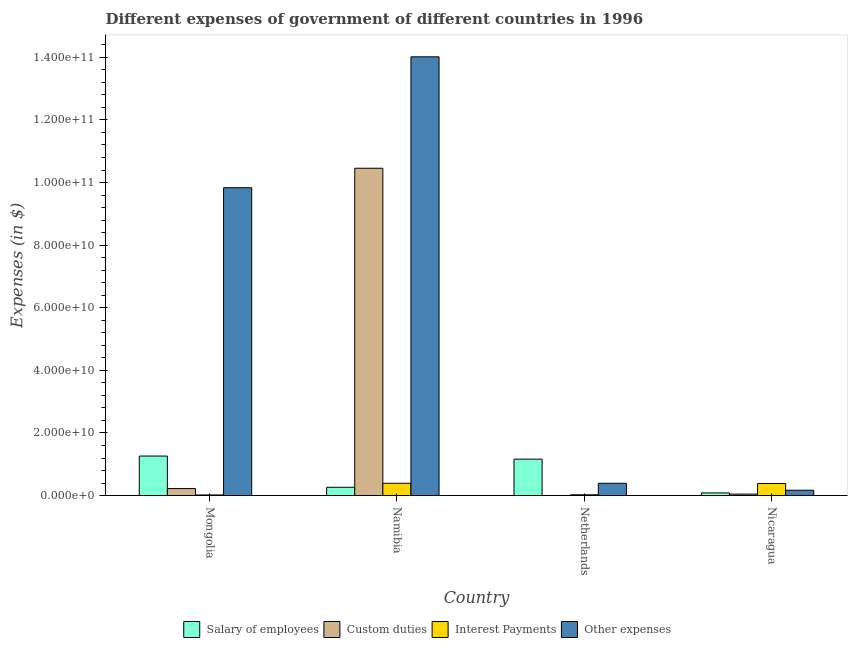How many different coloured bars are there?
Offer a terse response. 4. How many groups of bars are there?
Provide a succinct answer. 4. Are the number of bars per tick equal to the number of legend labels?
Keep it short and to the point. Yes. How many bars are there on the 4th tick from the right?
Your answer should be compact. 4. What is the label of the 4th group of bars from the left?
Offer a terse response. Nicaragua. What is the amount spent on interest payments in Netherlands?
Give a very brief answer. 2.50e+08. Across all countries, what is the maximum amount spent on custom duties?
Provide a short and direct response. 1.05e+11. Across all countries, what is the minimum amount spent on salary of employees?
Your answer should be compact. 8.45e+08. In which country was the amount spent on salary of employees maximum?
Ensure brevity in your answer.  Mongolia. In which country was the amount spent on other expenses minimum?
Your response must be concise. Nicaragua. What is the total amount spent on salary of employees in the graph?
Keep it short and to the point. 2.78e+1. What is the difference between the amount spent on other expenses in Mongolia and that in Netherlands?
Keep it short and to the point. 9.44e+1. What is the difference between the amount spent on salary of employees in Netherlands and the amount spent on other expenses in Namibia?
Your answer should be very brief. -1.29e+11. What is the average amount spent on salary of employees per country?
Offer a very short reply. 6.94e+09. What is the difference between the amount spent on interest payments and amount spent on other expenses in Mongolia?
Give a very brief answer. -9.81e+1. What is the ratio of the amount spent on custom duties in Netherlands to that in Nicaragua?
Offer a terse response. 0. What is the difference between the highest and the second highest amount spent on other expenses?
Your answer should be compact. 4.18e+1. What is the difference between the highest and the lowest amount spent on salary of employees?
Your answer should be very brief. 1.18e+1. Is it the case that in every country, the sum of the amount spent on custom duties and amount spent on salary of employees is greater than the sum of amount spent on other expenses and amount spent on interest payments?
Provide a succinct answer. No. What does the 3rd bar from the left in Mongolia represents?
Provide a short and direct response. Interest Payments. What does the 1st bar from the right in Namibia represents?
Provide a short and direct response. Other expenses. Are all the bars in the graph horizontal?
Your answer should be compact. No. How many countries are there in the graph?
Your answer should be compact. 4. What is the difference between two consecutive major ticks on the Y-axis?
Your answer should be compact. 2.00e+1. Are the values on the major ticks of Y-axis written in scientific E-notation?
Your answer should be very brief. Yes. Does the graph contain any zero values?
Offer a terse response. No. Where does the legend appear in the graph?
Keep it short and to the point. Bottom center. How are the legend labels stacked?
Provide a short and direct response. Horizontal. What is the title of the graph?
Your response must be concise. Different expenses of government of different countries in 1996. What is the label or title of the Y-axis?
Ensure brevity in your answer.  Expenses (in $). What is the Expenses (in $) in Salary of employees in Mongolia?
Make the answer very short. 1.26e+1. What is the Expenses (in $) in Custom duties in Mongolia?
Ensure brevity in your answer.  2.23e+09. What is the Expenses (in $) of Interest Payments in Mongolia?
Give a very brief answer. 1.99e+08. What is the Expenses (in $) in Other expenses in Mongolia?
Offer a terse response. 9.83e+1. What is the Expenses (in $) of Salary of employees in Namibia?
Provide a succinct answer. 2.65e+09. What is the Expenses (in $) of Custom duties in Namibia?
Keep it short and to the point. 1.05e+11. What is the Expenses (in $) of Interest Payments in Namibia?
Offer a terse response. 3.93e+09. What is the Expenses (in $) of Other expenses in Namibia?
Ensure brevity in your answer.  1.40e+11. What is the Expenses (in $) in Salary of employees in Netherlands?
Ensure brevity in your answer.  1.16e+1. What is the Expenses (in $) in Custom duties in Netherlands?
Provide a short and direct response. 7.70e+05. What is the Expenses (in $) of Interest Payments in Netherlands?
Offer a very short reply. 2.50e+08. What is the Expenses (in $) in Other expenses in Netherlands?
Keep it short and to the point. 3.93e+09. What is the Expenses (in $) in Salary of employees in Nicaragua?
Offer a very short reply. 8.45e+08. What is the Expenses (in $) in Custom duties in Nicaragua?
Provide a succinct answer. 4.63e+08. What is the Expenses (in $) in Interest Payments in Nicaragua?
Provide a succinct answer. 3.87e+09. What is the Expenses (in $) in Other expenses in Nicaragua?
Provide a short and direct response. 1.71e+09. Across all countries, what is the maximum Expenses (in $) in Salary of employees?
Offer a terse response. 1.26e+1. Across all countries, what is the maximum Expenses (in $) in Custom duties?
Offer a very short reply. 1.05e+11. Across all countries, what is the maximum Expenses (in $) in Interest Payments?
Your answer should be compact. 3.93e+09. Across all countries, what is the maximum Expenses (in $) in Other expenses?
Offer a terse response. 1.40e+11. Across all countries, what is the minimum Expenses (in $) of Salary of employees?
Provide a short and direct response. 8.45e+08. Across all countries, what is the minimum Expenses (in $) of Custom duties?
Keep it short and to the point. 7.70e+05. Across all countries, what is the minimum Expenses (in $) of Interest Payments?
Ensure brevity in your answer.  1.99e+08. Across all countries, what is the minimum Expenses (in $) in Other expenses?
Your answer should be compact. 1.71e+09. What is the total Expenses (in $) of Salary of employees in the graph?
Ensure brevity in your answer.  2.78e+1. What is the total Expenses (in $) in Custom duties in the graph?
Ensure brevity in your answer.  1.07e+11. What is the total Expenses (in $) in Interest Payments in the graph?
Your answer should be very brief. 8.25e+09. What is the total Expenses (in $) in Other expenses in the graph?
Your answer should be very brief. 2.44e+11. What is the difference between the Expenses (in $) in Salary of employees in Mongolia and that in Namibia?
Ensure brevity in your answer.  9.97e+09. What is the difference between the Expenses (in $) of Custom duties in Mongolia and that in Namibia?
Your answer should be very brief. -1.02e+11. What is the difference between the Expenses (in $) in Interest Payments in Mongolia and that in Namibia?
Make the answer very short. -3.73e+09. What is the difference between the Expenses (in $) in Other expenses in Mongolia and that in Namibia?
Give a very brief answer. -4.18e+1. What is the difference between the Expenses (in $) of Salary of employees in Mongolia and that in Netherlands?
Offer a very short reply. 9.81e+08. What is the difference between the Expenses (in $) of Custom duties in Mongolia and that in Netherlands?
Make the answer very short. 2.23e+09. What is the difference between the Expenses (in $) in Interest Payments in Mongolia and that in Netherlands?
Your response must be concise. -5.11e+07. What is the difference between the Expenses (in $) in Other expenses in Mongolia and that in Netherlands?
Provide a short and direct response. 9.44e+1. What is the difference between the Expenses (in $) in Salary of employees in Mongolia and that in Nicaragua?
Keep it short and to the point. 1.18e+1. What is the difference between the Expenses (in $) in Custom duties in Mongolia and that in Nicaragua?
Offer a terse response. 1.77e+09. What is the difference between the Expenses (in $) in Interest Payments in Mongolia and that in Nicaragua?
Give a very brief answer. -3.67e+09. What is the difference between the Expenses (in $) in Other expenses in Mongolia and that in Nicaragua?
Give a very brief answer. 9.66e+1. What is the difference between the Expenses (in $) in Salary of employees in Namibia and that in Netherlands?
Keep it short and to the point. -8.99e+09. What is the difference between the Expenses (in $) of Custom duties in Namibia and that in Netherlands?
Provide a short and direct response. 1.05e+11. What is the difference between the Expenses (in $) in Interest Payments in Namibia and that in Netherlands?
Offer a terse response. 3.68e+09. What is the difference between the Expenses (in $) of Other expenses in Namibia and that in Netherlands?
Ensure brevity in your answer.  1.36e+11. What is the difference between the Expenses (in $) of Salary of employees in Namibia and that in Nicaragua?
Make the answer very short. 1.81e+09. What is the difference between the Expenses (in $) of Custom duties in Namibia and that in Nicaragua?
Offer a very short reply. 1.04e+11. What is the difference between the Expenses (in $) of Interest Payments in Namibia and that in Nicaragua?
Make the answer very short. 6.50e+07. What is the difference between the Expenses (in $) in Other expenses in Namibia and that in Nicaragua?
Make the answer very short. 1.38e+11. What is the difference between the Expenses (in $) of Salary of employees in Netherlands and that in Nicaragua?
Make the answer very short. 1.08e+1. What is the difference between the Expenses (in $) of Custom duties in Netherlands and that in Nicaragua?
Offer a very short reply. -4.62e+08. What is the difference between the Expenses (in $) in Interest Payments in Netherlands and that in Nicaragua?
Provide a succinct answer. -3.62e+09. What is the difference between the Expenses (in $) of Other expenses in Netherlands and that in Nicaragua?
Your answer should be compact. 2.22e+09. What is the difference between the Expenses (in $) in Salary of employees in Mongolia and the Expenses (in $) in Custom duties in Namibia?
Provide a short and direct response. -9.19e+1. What is the difference between the Expenses (in $) of Salary of employees in Mongolia and the Expenses (in $) of Interest Payments in Namibia?
Offer a terse response. 8.69e+09. What is the difference between the Expenses (in $) of Salary of employees in Mongolia and the Expenses (in $) of Other expenses in Namibia?
Make the answer very short. -1.28e+11. What is the difference between the Expenses (in $) of Custom duties in Mongolia and the Expenses (in $) of Interest Payments in Namibia?
Offer a very short reply. -1.70e+09. What is the difference between the Expenses (in $) in Custom duties in Mongolia and the Expenses (in $) in Other expenses in Namibia?
Offer a terse response. -1.38e+11. What is the difference between the Expenses (in $) in Interest Payments in Mongolia and the Expenses (in $) in Other expenses in Namibia?
Give a very brief answer. -1.40e+11. What is the difference between the Expenses (in $) in Salary of employees in Mongolia and the Expenses (in $) in Custom duties in Netherlands?
Give a very brief answer. 1.26e+1. What is the difference between the Expenses (in $) in Salary of employees in Mongolia and the Expenses (in $) in Interest Payments in Netherlands?
Your answer should be very brief. 1.24e+1. What is the difference between the Expenses (in $) in Salary of employees in Mongolia and the Expenses (in $) in Other expenses in Netherlands?
Offer a very short reply. 8.69e+09. What is the difference between the Expenses (in $) in Custom duties in Mongolia and the Expenses (in $) in Interest Payments in Netherlands?
Keep it short and to the point. 1.98e+09. What is the difference between the Expenses (in $) in Custom duties in Mongolia and the Expenses (in $) in Other expenses in Netherlands?
Your response must be concise. -1.69e+09. What is the difference between the Expenses (in $) in Interest Payments in Mongolia and the Expenses (in $) in Other expenses in Netherlands?
Ensure brevity in your answer.  -3.73e+09. What is the difference between the Expenses (in $) in Salary of employees in Mongolia and the Expenses (in $) in Custom duties in Nicaragua?
Your response must be concise. 1.22e+1. What is the difference between the Expenses (in $) in Salary of employees in Mongolia and the Expenses (in $) in Interest Payments in Nicaragua?
Give a very brief answer. 8.75e+09. What is the difference between the Expenses (in $) of Salary of employees in Mongolia and the Expenses (in $) of Other expenses in Nicaragua?
Your answer should be very brief. 1.09e+1. What is the difference between the Expenses (in $) in Custom duties in Mongolia and the Expenses (in $) in Interest Payments in Nicaragua?
Ensure brevity in your answer.  -1.64e+09. What is the difference between the Expenses (in $) of Custom duties in Mongolia and the Expenses (in $) of Other expenses in Nicaragua?
Keep it short and to the point. 5.26e+08. What is the difference between the Expenses (in $) in Interest Payments in Mongolia and the Expenses (in $) in Other expenses in Nicaragua?
Keep it short and to the point. -1.51e+09. What is the difference between the Expenses (in $) of Salary of employees in Namibia and the Expenses (in $) of Custom duties in Netherlands?
Your answer should be compact. 2.65e+09. What is the difference between the Expenses (in $) in Salary of employees in Namibia and the Expenses (in $) in Interest Payments in Netherlands?
Your response must be concise. 2.40e+09. What is the difference between the Expenses (in $) of Salary of employees in Namibia and the Expenses (in $) of Other expenses in Netherlands?
Offer a terse response. -1.28e+09. What is the difference between the Expenses (in $) in Custom duties in Namibia and the Expenses (in $) in Interest Payments in Netherlands?
Provide a short and direct response. 1.04e+11. What is the difference between the Expenses (in $) of Custom duties in Namibia and the Expenses (in $) of Other expenses in Netherlands?
Keep it short and to the point. 1.01e+11. What is the difference between the Expenses (in $) in Interest Payments in Namibia and the Expenses (in $) in Other expenses in Netherlands?
Your response must be concise. 6.96e+06. What is the difference between the Expenses (in $) of Salary of employees in Namibia and the Expenses (in $) of Custom duties in Nicaragua?
Your answer should be compact. 2.19e+09. What is the difference between the Expenses (in $) in Salary of employees in Namibia and the Expenses (in $) in Interest Payments in Nicaragua?
Your response must be concise. -1.22e+09. What is the difference between the Expenses (in $) in Salary of employees in Namibia and the Expenses (in $) in Other expenses in Nicaragua?
Give a very brief answer. 9.43e+08. What is the difference between the Expenses (in $) in Custom duties in Namibia and the Expenses (in $) in Interest Payments in Nicaragua?
Your answer should be compact. 1.01e+11. What is the difference between the Expenses (in $) of Custom duties in Namibia and the Expenses (in $) of Other expenses in Nicaragua?
Keep it short and to the point. 1.03e+11. What is the difference between the Expenses (in $) of Interest Payments in Namibia and the Expenses (in $) of Other expenses in Nicaragua?
Your answer should be compact. 2.23e+09. What is the difference between the Expenses (in $) in Salary of employees in Netherlands and the Expenses (in $) in Custom duties in Nicaragua?
Give a very brief answer. 1.12e+1. What is the difference between the Expenses (in $) in Salary of employees in Netherlands and the Expenses (in $) in Interest Payments in Nicaragua?
Your response must be concise. 7.77e+09. What is the difference between the Expenses (in $) in Salary of employees in Netherlands and the Expenses (in $) in Other expenses in Nicaragua?
Provide a succinct answer. 9.93e+09. What is the difference between the Expenses (in $) in Custom duties in Netherlands and the Expenses (in $) in Interest Payments in Nicaragua?
Your answer should be very brief. -3.87e+09. What is the difference between the Expenses (in $) of Custom duties in Netherlands and the Expenses (in $) of Other expenses in Nicaragua?
Your response must be concise. -1.71e+09. What is the difference between the Expenses (in $) in Interest Payments in Netherlands and the Expenses (in $) in Other expenses in Nicaragua?
Make the answer very short. -1.46e+09. What is the average Expenses (in $) in Salary of employees per country?
Your answer should be compact. 6.94e+09. What is the average Expenses (in $) of Custom duties per country?
Provide a succinct answer. 2.68e+1. What is the average Expenses (in $) of Interest Payments per country?
Keep it short and to the point. 2.06e+09. What is the average Expenses (in $) of Other expenses per country?
Your response must be concise. 6.10e+1. What is the difference between the Expenses (in $) of Salary of employees and Expenses (in $) of Custom duties in Mongolia?
Give a very brief answer. 1.04e+1. What is the difference between the Expenses (in $) of Salary of employees and Expenses (in $) of Interest Payments in Mongolia?
Your response must be concise. 1.24e+1. What is the difference between the Expenses (in $) of Salary of employees and Expenses (in $) of Other expenses in Mongolia?
Provide a short and direct response. -8.57e+1. What is the difference between the Expenses (in $) in Custom duties and Expenses (in $) in Interest Payments in Mongolia?
Your answer should be compact. 2.03e+09. What is the difference between the Expenses (in $) in Custom duties and Expenses (in $) in Other expenses in Mongolia?
Your response must be concise. -9.61e+1. What is the difference between the Expenses (in $) in Interest Payments and Expenses (in $) in Other expenses in Mongolia?
Ensure brevity in your answer.  -9.81e+1. What is the difference between the Expenses (in $) of Salary of employees and Expenses (in $) of Custom duties in Namibia?
Your response must be concise. -1.02e+11. What is the difference between the Expenses (in $) in Salary of employees and Expenses (in $) in Interest Payments in Namibia?
Your answer should be compact. -1.28e+09. What is the difference between the Expenses (in $) of Salary of employees and Expenses (in $) of Other expenses in Namibia?
Offer a terse response. -1.38e+11. What is the difference between the Expenses (in $) in Custom duties and Expenses (in $) in Interest Payments in Namibia?
Offer a terse response. 1.01e+11. What is the difference between the Expenses (in $) in Custom duties and Expenses (in $) in Other expenses in Namibia?
Keep it short and to the point. -3.56e+1. What is the difference between the Expenses (in $) in Interest Payments and Expenses (in $) in Other expenses in Namibia?
Give a very brief answer. -1.36e+11. What is the difference between the Expenses (in $) of Salary of employees and Expenses (in $) of Custom duties in Netherlands?
Your answer should be compact. 1.16e+1. What is the difference between the Expenses (in $) in Salary of employees and Expenses (in $) in Interest Payments in Netherlands?
Keep it short and to the point. 1.14e+1. What is the difference between the Expenses (in $) of Salary of employees and Expenses (in $) of Other expenses in Netherlands?
Your answer should be compact. 7.71e+09. What is the difference between the Expenses (in $) of Custom duties and Expenses (in $) of Interest Payments in Netherlands?
Keep it short and to the point. -2.50e+08. What is the difference between the Expenses (in $) in Custom duties and Expenses (in $) in Other expenses in Netherlands?
Provide a succinct answer. -3.93e+09. What is the difference between the Expenses (in $) of Interest Payments and Expenses (in $) of Other expenses in Netherlands?
Provide a succinct answer. -3.68e+09. What is the difference between the Expenses (in $) of Salary of employees and Expenses (in $) of Custom duties in Nicaragua?
Give a very brief answer. 3.82e+08. What is the difference between the Expenses (in $) in Salary of employees and Expenses (in $) in Interest Payments in Nicaragua?
Provide a short and direct response. -3.02e+09. What is the difference between the Expenses (in $) in Salary of employees and Expenses (in $) in Other expenses in Nicaragua?
Offer a terse response. -8.62e+08. What is the difference between the Expenses (in $) in Custom duties and Expenses (in $) in Interest Payments in Nicaragua?
Your answer should be very brief. -3.41e+09. What is the difference between the Expenses (in $) in Custom duties and Expenses (in $) in Other expenses in Nicaragua?
Offer a very short reply. -1.24e+09. What is the difference between the Expenses (in $) of Interest Payments and Expenses (in $) of Other expenses in Nicaragua?
Your answer should be compact. 2.16e+09. What is the ratio of the Expenses (in $) in Salary of employees in Mongolia to that in Namibia?
Ensure brevity in your answer.  4.76. What is the ratio of the Expenses (in $) in Custom duties in Mongolia to that in Namibia?
Your answer should be very brief. 0.02. What is the ratio of the Expenses (in $) in Interest Payments in Mongolia to that in Namibia?
Provide a succinct answer. 0.05. What is the ratio of the Expenses (in $) of Other expenses in Mongolia to that in Namibia?
Make the answer very short. 0.7. What is the ratio of the Expenses (in $) in Salary of employees in Mongolia to that in Netherlands?
Give a very brief answer. 1.08. What is the ratio of the Expenses (in $) in Custom duties in Mongolia to that in Netherlands?
Offer a very short reply. 2899.03. What is the ratio of the Expenses (in $) of Interest Payments in Mongolia to that in Netherlands?
Make the answer very short. 0.8. What is the ratio of the Expenses (in $) of Other expenses in Mongolia to that in Netherlands?
Offer a terse response. 25.05. What is the ratio of the Expenses (in $) of Salary of employees in Mongolia to that in Nicaragua?
Offer a terse response. 14.94. What is the ratio of the Expenses (in $) in Custom duties in Mongolia to that in Nicaragua?
Offer a terse response. 4.83. What is the ratio of the Expenses (in $) of Interest Payments in Mongolia to that in Nicaragua?
Your response must be concise. 0.05. What is the ratio of the Expenses (in $) of Other expenses in Mongolia to that in Nicaragua?
Provide a short and direct response. 57.63. What is the ratio of the Expenses (in $) of Salary of employees in Namibia to that in Netherlands?
Keep it short and to the point. 0.23. What is the ratio of the Expenses (in $) of Custom duties in Namibia to that in Netherlands?
Make the answer very short. 1.36e+05. What is the ratio of the Expenses (in $) in Interest Payments in Namibia to that in Netherlands?
Provide a short and direct response. 15.7. What is the ratio of the Expenses (in $) in Other expenses in Namibia to that in Netherlands?
Offer a terse response. 35.7. What is the ratio of the Expenses (in $) in Salary of employees in Namibia to that in Nicaragua?
Ensure brevity in your answer.  3.14. What is the ratio of the Expenses (in $) of Custom duties in Namibia to that in Nicaragua?
Offer a very short reply. 226.04. What is the ratio of the Expenses (in $) of Interest Payments in Namibia to that in Nicaragua?
Provide a succinct answer. 1.02. What is the ratio of the Expenses (in $) of Other expenses in Namibia to that in Nicaragua?
Make the answer very short. 82.14. What is the ratio of the Expenses (in $) of Salary of employees in Netherlands to that in Nicaragua?
Keep it short and to the point. 13.78. What is the ratio of the Expenses (in $) of Custom duties in Netherlands to that in Nicaragua?
Offer a terse response. 0. What is the ratio of the Expenses (in $) in Interest Payments in Netherlands to that in Nicaragua?
Provide a succinct answer. 0.06. What is the ratio of the Expenses (in $) in Other expenses in Netherlands to that in Nicaragua?
Provide a succinct answer. 2.3. What is the difference between the highest and the second highest Expenses (in $) of Salary of employees?
Provide a short and direct response. 9.81e+08. What is the difference between the highest and the second highest Expenses (in $) in Custom duties?
Offer a terse response. 1.02e+11. What is the difference between the highest and the second highest Expenses (in $) of Interest Payments?
Offer a terse response. 6.50e+07. What is the difference between the highest and the second highest Expenses (in $) of Other expenses?
Provide a short and direct response. 4.18e+1. What is the difference between the highest and the lowest Expenses (in $) of Salary of employees?
Your answer should be compact. 1.18e+1. What is the difference between the highest and the lowest Expenses (in $) of Custom duties?
Keep it short and to the point. 1.05e+11. What is the difference between the highest and the lowest Expenses (in $) in Interest Payments?
Your answer should be compact. 3.73e+09. What is the difference between the highest and the lowest Expenses (in $) of Other expenses?
Your answer should be compact. 1.38e+11. 